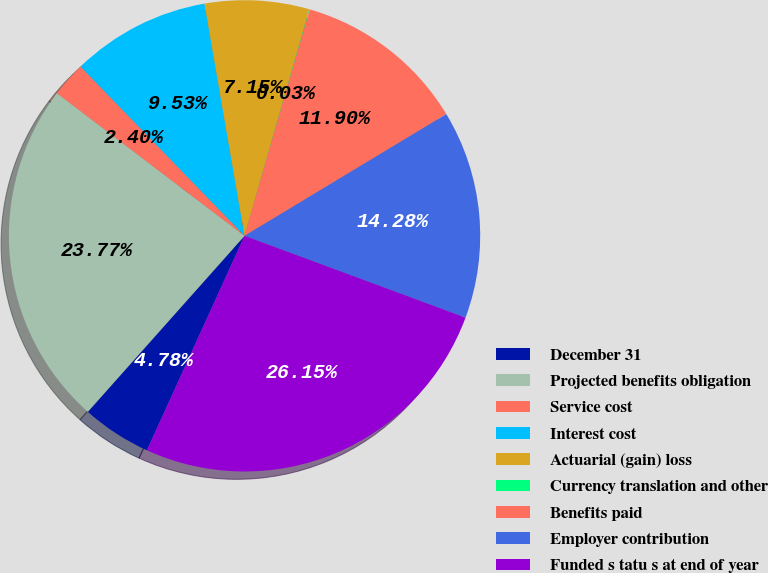Convert chart. <chart><loc_0><loc_0><loc_500><loc_500><pie_chart><fcel>December 31<fcel>Projected benefits obligation<fcel>Service cost<fcel>Interest cost<fcel>Actuarial (gain) loss<fcel>Currency translation and other<fcel>Benefits paid<fcel>Employer contribution<fcel>Funded s tatu s at end of year<nl><fcel>4.78%<fcel>23.77%<fcel>2.4%<fcel>9.53%<fcel>7.15%<fcel>0.03%<fcel>11.9%<fcel>14.28%<fcel>26.15%<nl></chart> 